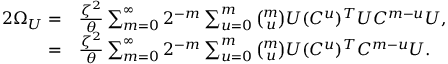<formula> <loc_0><loc_0><loc_500><loc_500>\begin{array} { r l } { 2 \Omega _ { U } = } & { \frac { \zeta ^ { 2 } } { \theta } \sum _ { m = 0 } ^ { \infty } { 2 ^ { - m } \sum _ { u = 0 } ^ { m } { \binom { m } { u } U ( C ^ { u } ) ^ { T } U C ^ { m - u } } U } , } \\ { = } & { \frac { \zeta ^ { 2 } } { \theta } \sum _ { m = 0 } ^ { \infty } { 2 ^ { - m } \sum _ { u = 0 } ^ { m } { \binom { m } { u } U ( C ^ { u } ) ^ { T } C ^ { m - u } } U } . } \end{array}</formula> 